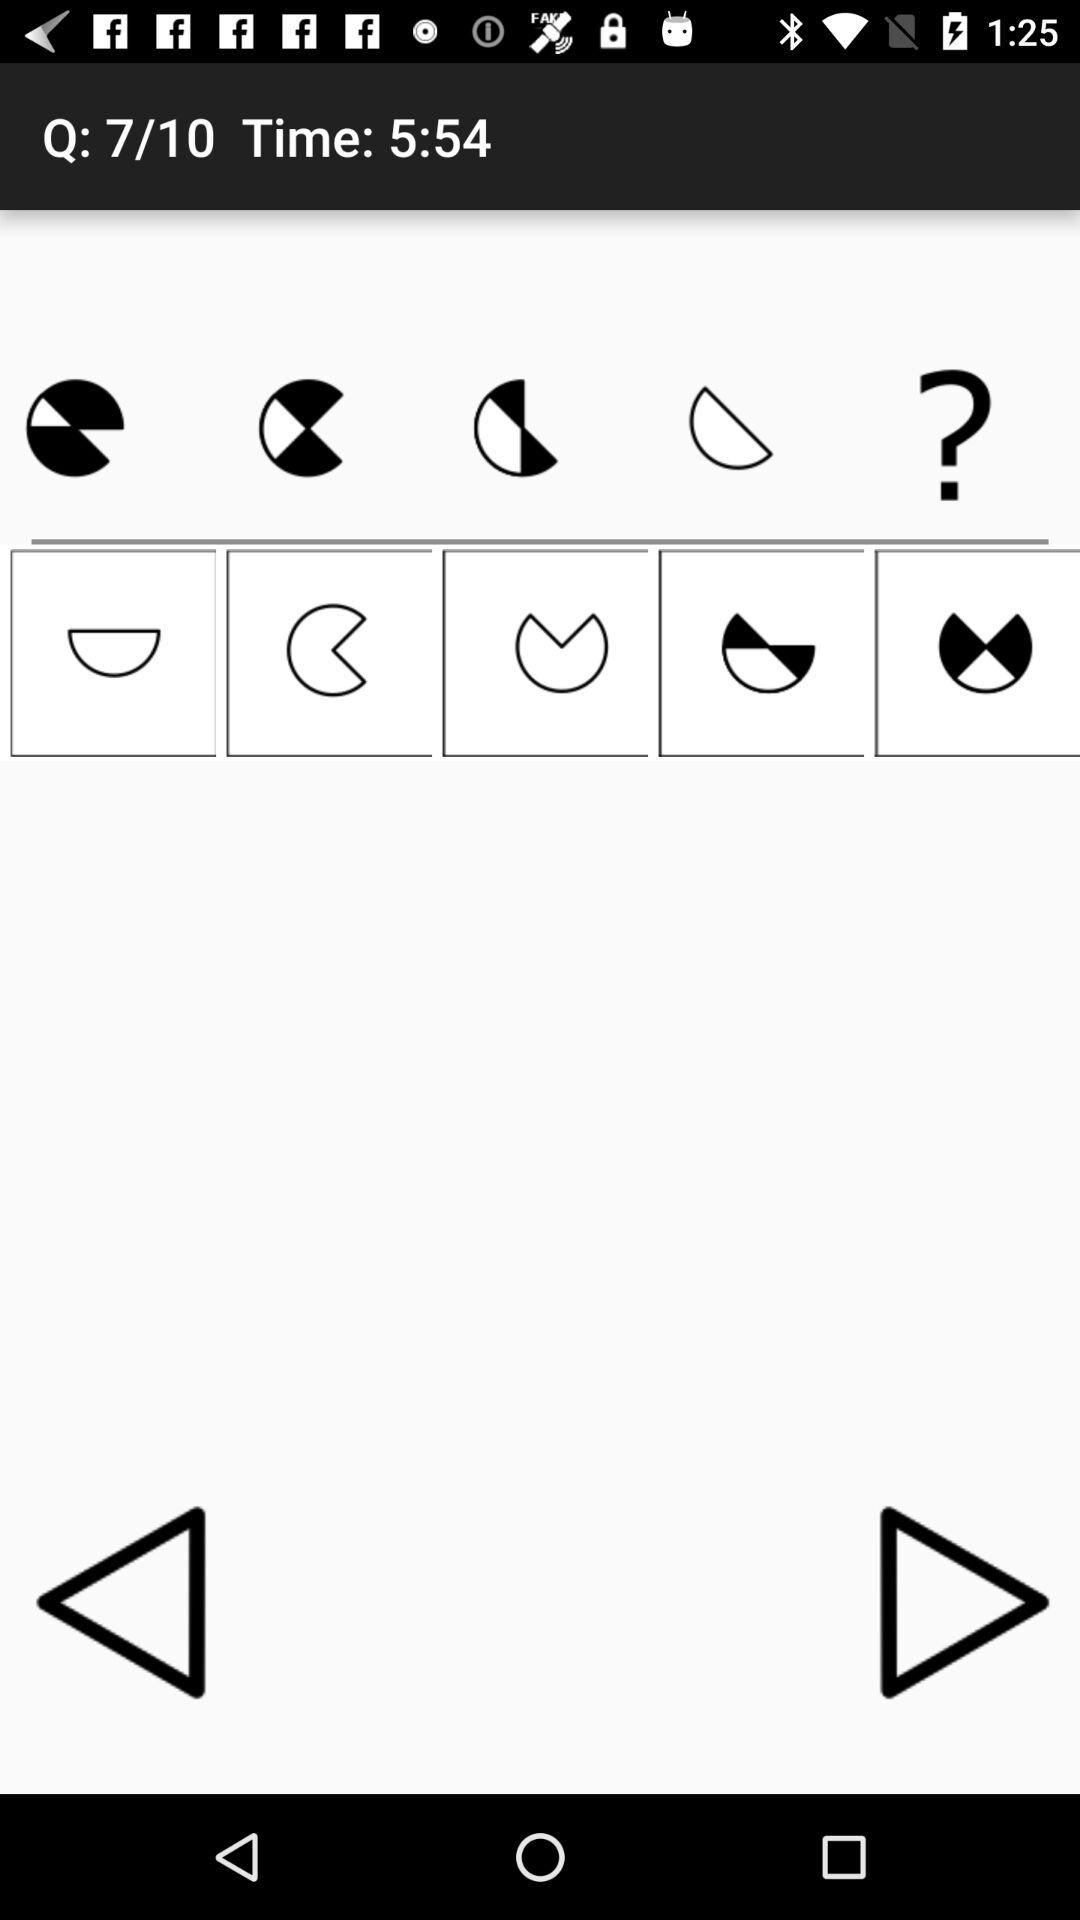How many questions were correct?
When the provided information is insufficient, respond with <no answer>. <no answer> 